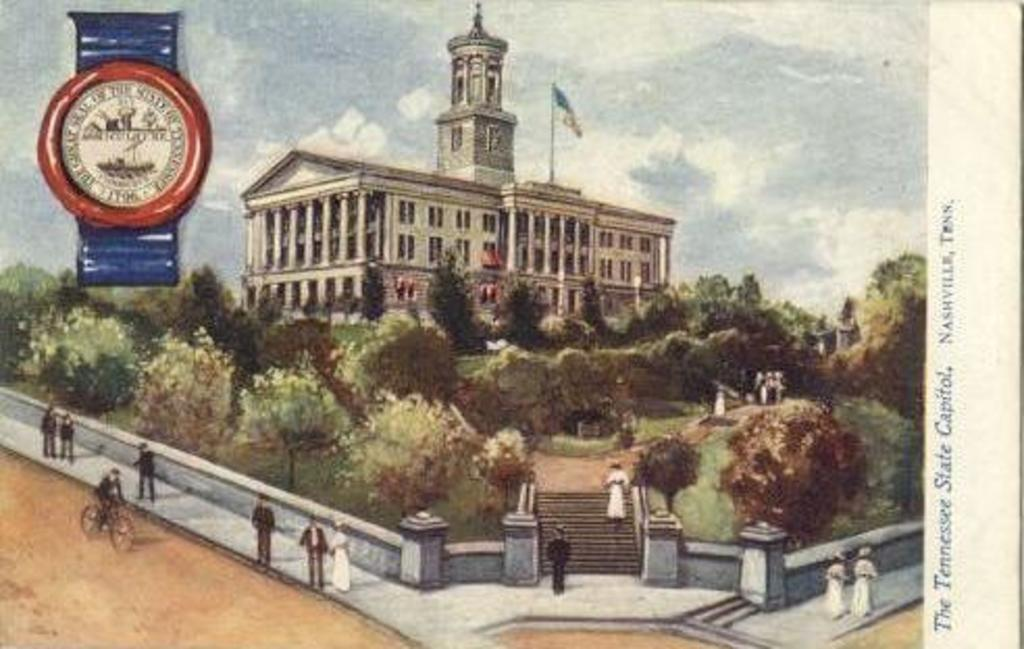<image>
Give a short and clear explanation of the subsequent image. A painting of a white building at the Tennessee State Capitol. 